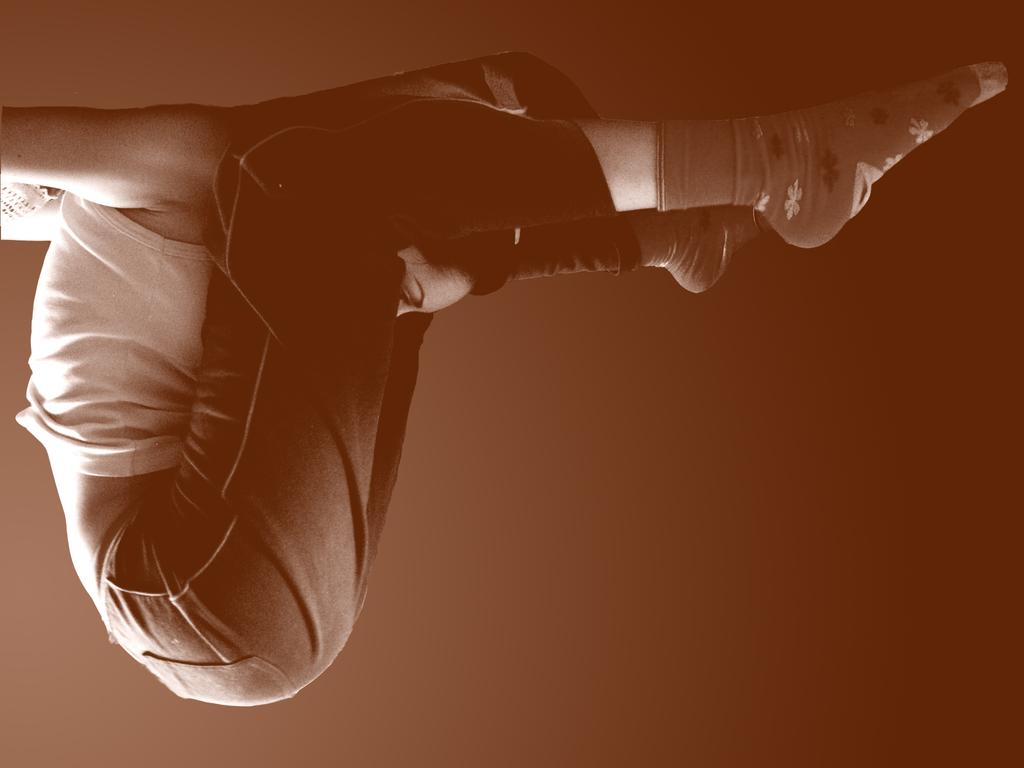Who is the main subject in the image? There is a woman in the center of the image. What is the woman doing in the image? The woman is doing exercise. What is the woman wearing in the image? The woman is wearing a white t-shirt. Can you describe the background of the image? The background of the image is blurred. What type of grain is being used as a prop in the image? There is no grain present in the image; it features a woman doing exercise with a blurred background. 